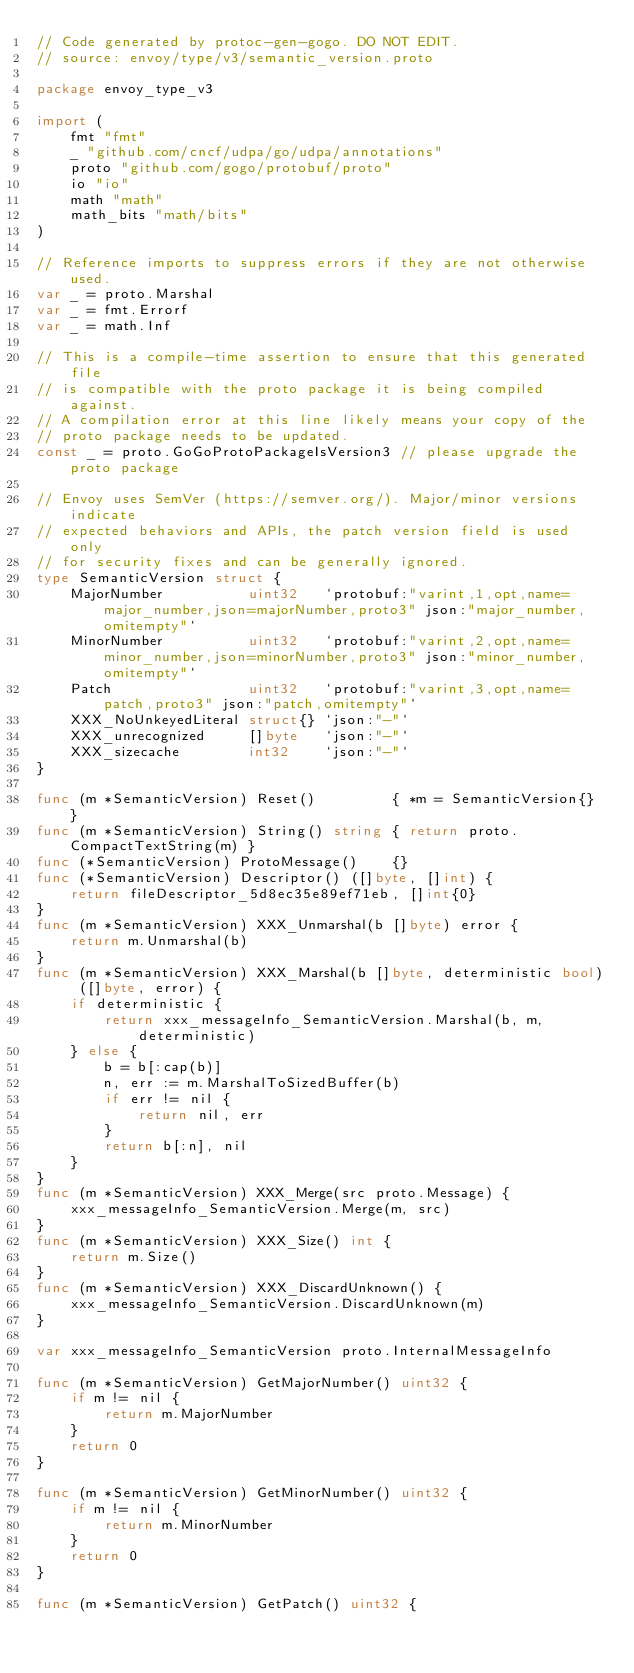<code> <loc_0><loc_0><loc_500><loc_500><_Go_>// Code generated by protoc-gen-gogo. DO NOT EDIT.
// source: envoy/type/v3/semantic_version.proto

package envoy_type_v3

import (
	fmt "fmt"
	_ "github.com/cncf/udpa/go/udpa/annotations"
	proto "github.com/gogo/protobuf/proto"
	io "io"
	math "math"
	math_bits "math/bits"
)

// Reference imports to suppress errors if they are not otherwise used.
var _ = proto.Marshal
var _ = fmt.Errorf
var _ = math.Inf

// This is a compile-time assertion to ensure that this generated file
// is compatible with the proto package it is being compiled against.
// A compilation error at this line likely means your copy of the
// proto package needs to be updated.
const _ = proto.GoGoProtoPackageIsVersion3 // please upgrade the proto package

// Envoy uses SemVer (https://semver.org/). Major/minor versions indicate
// expected behaviors and APIs, the patch version field is used only
// for security fixes and can be generally ignored.
type SemanticVersion struct {
	MajorNumber          uint32   `protobuf:"varint,1,opt,name=major_number,json=majorNumber,proto3" json:"major_number,omitempty"`
	MinorNumber          uint32   `protobuf:"varint,2,opt,name=minor_number,json=minorNumber,proto3" json:"minor_number,omitempty"`
	Patch                uint32   `protobuf:"varint,3,opt,name=patch,proto3" json:"patch,omitempty"`
	XXX_NoUnkeyedLiteral struct{} `json:"-"`
	XXX_unrecognized     []byte   `json:"-"`
	XXX_sizecache        int32    `json:"-"`
}

func (m *SemanticVersion) Reset()         { *m = SemanticVersion{} }
func (m *SemanticVersion) String() string { return proto.CompactTextString(m) }
func (*SemanticVersion) ProtoMessage()    {}
func (*SemanticVersion) Descriptor() ([]byte, []int) {
	return fileDescriptor_5d8ec35e89ef71eb, []int{0}
}
func (m *SemanticVersion) XXX_Unmarshal(b []byte) error {
	return m.Unmarshal(b)
}
func (m *SemanticVersion) XXX_Marshal(b []byte, deterministic bool) ([]byte, error) {
	if deterministic {
		return xxx_messageInfo_SemanticVersion.Marshal(b, m, deterministic)
	} else {
		b = b[:cap(b)]
		n, err := m.MarshalToSizedBuffer(b)
		if err != nil {
			return nil, err
		}
		return b[:n], nil
	}
}
func (m *SemanticVersion) XXX_Merge(src proto.Message) {
	xxx_messageInfo_SemanticVersion.Merge(m, src)
}
func (m *SemanticVersion) XXX_Size() int {
	return m.Size()
}
func (m *SemanticVersion) XXX_DiscardUnknown() {
	xxx_messageInfo_SemanticVersion.DiscardUnknown(m)
}

var xxx_messageInfo_SemanticVersion proto.InternalMessageInfo

func (m *SemanticVersion) GetMajorNumber() uint32 {
	if m != nil {
		return m.MajorNumber
	}
	return 0
}

func (m *SemanticVersion) GetMinorNumber() uint32 {
	if m != nil {
		return m.MinorNumber
	}
	return 0
}

func (m *SemanticVersion) GetPatch() uint32 {</code> 